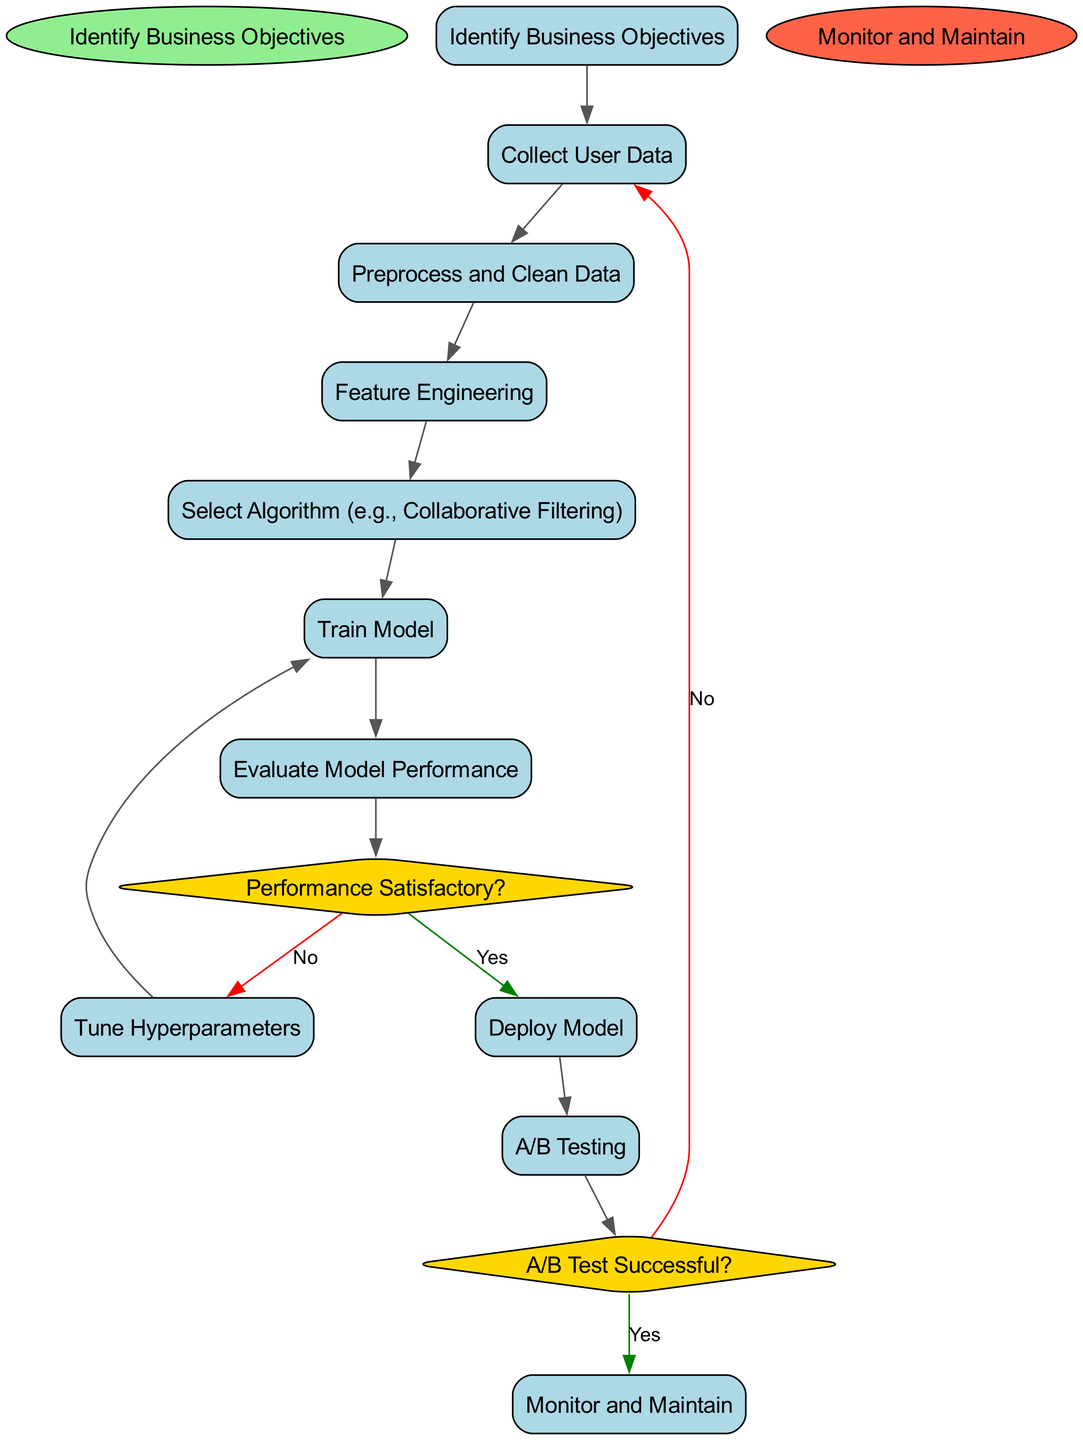What is the starting node of the process? The starting node is labeled "Identify Business Objectives," marking the beginning of the iterative process.
Answer: Identify Business Objectives How many activities are present in the diagram? There are a total of nine activities listed in the diagram, indicating the steps taken in the process of developing the recommendation system.
Answer: 9 What is the last node in the process? The end node of the process is labeled "Monitor and Maintain," which represents the final step after deploying the model.
Answer: Monitor and Maintain Which node comes after "Evaluate Model Performance"? The next node after "Evaluate Model Performance" is a decision point asking "Performance Satisfactory?", which determines whether to deploy the model or tune hyperparameters.
Answer: Performance Satisfactory? What happens if the answer to "A/B Test Successful?" is 'No'? If the answer is 'No', the flow returns to "Collect User Data," indicating that further data collection is necessary to improve the recommendation system after an unsuccessful A/B test.
Answer: Collect User Data How many decision nodes are present in the diagram? There are two decision nodes present: one asking if the performance is satisfactory and the other asking if the A/B test is successful.
Answer: 2 What is the activity that follows "Train Model"? The activity that follows "Train Model" is "Evaluate Model Performance," where the trained model is assessed for its effectiveness in making recommendations.
Answer: Evaluate Model Performance Which activity precedes "Feature Engineering"? The activity that comes before "Feature Engineering" is "Preprocess and Clean Data," which prepares the collected data for engineering features relevant to the recommendation system.
Answer: Preprocess and Clean Data What would happen if "Performance Satisfactory?" is answered with 'Yes'? Answering 'Yes' would lead to the "Deploy Model" stage, indicating that the model is ready to be utilized in a real-world setting.
Answer: Deploy Model 